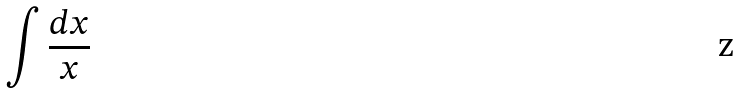<formula> <loc_0><loc_0><loc_500><loc_500>\int \frac { d x } { x }</formula> 